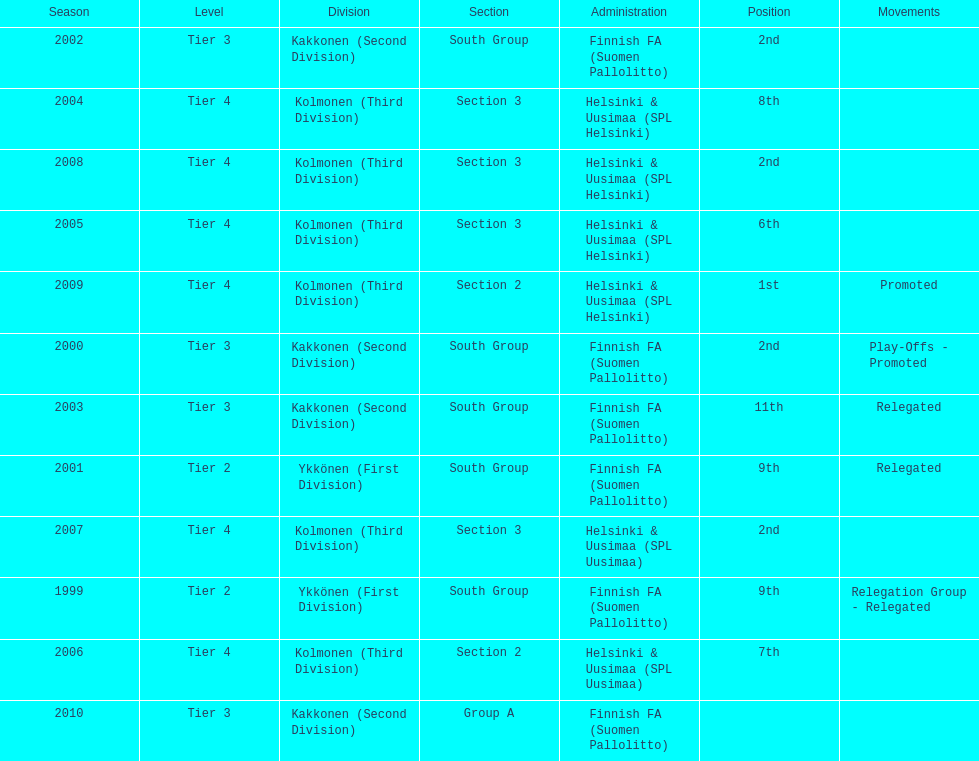Which was the only kolmonen whose movements were promoted? 2009. 